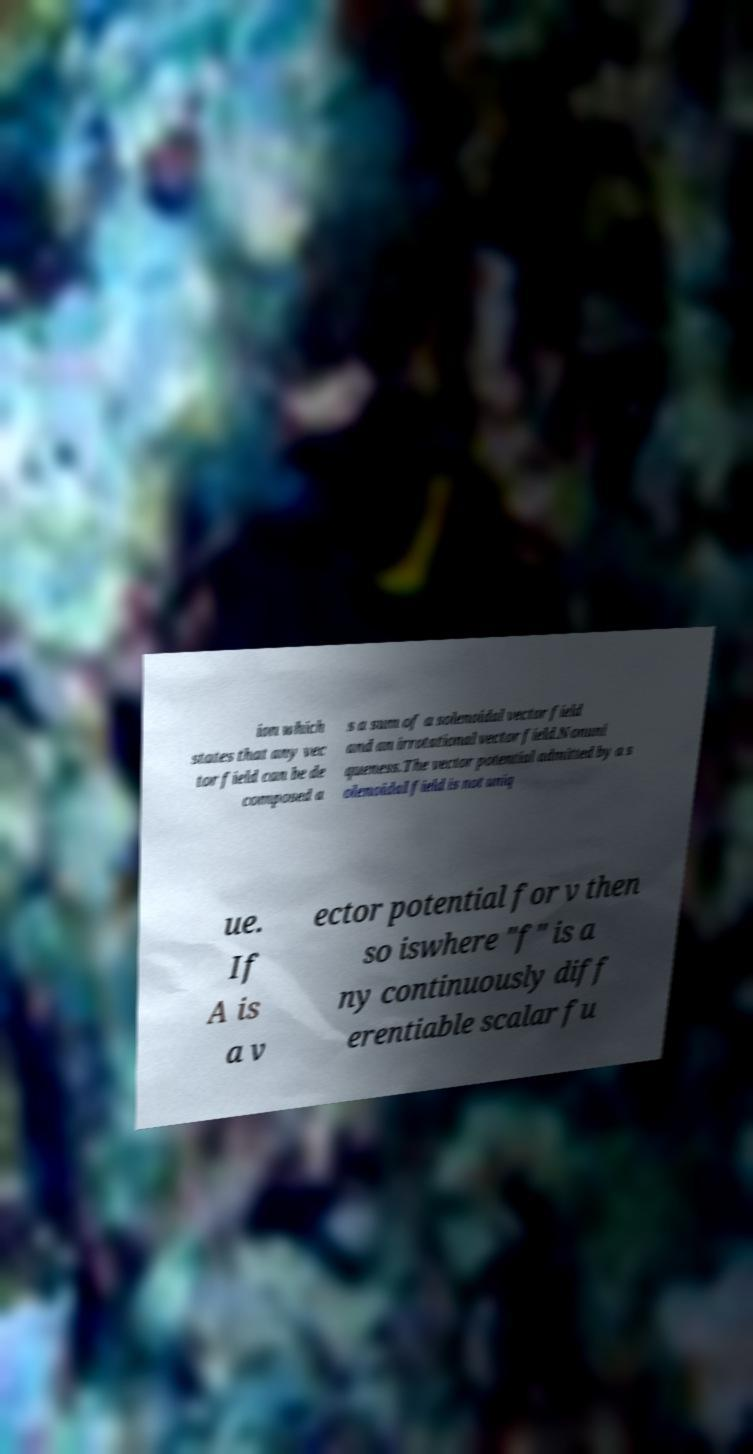What messages or text are displayed in this image? I need them in a readable, typed format. ion which states that any vec tor field can be de composed a s a sum of a solenoidal vector field and an irrotational vector field.Nonuni queness.The vector potential admitted by a s olenoidal field is not uniq ue. If A is a v ector potential for v then so iswhere "f" is a ny continuously diff erentiable scalar fu 